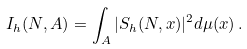<formula> <loc_0><loc_0><loc_500><loc_500>I _ { h } ( N , A ) = \int _ { A } | S _ { h } ( N , x ) | ^ { 2 } d \mu ( x ) \, .</formula> 